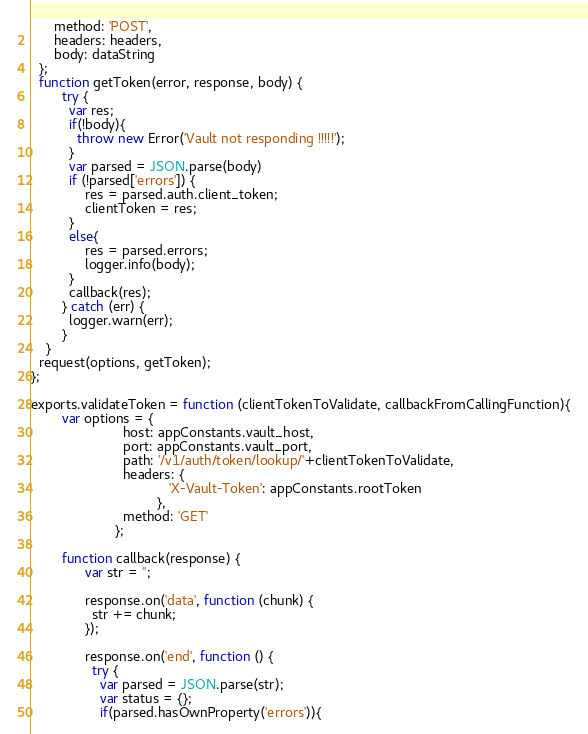<code> <loc_0><loc_0><loc_500><loc_500><_JavaScript_>      method: 'POST',
      headers: headers,
      body: dataString
  };
  function getToken(error, response, body) {
        try {
          var res;
          if(!body){
            throw new Error('Vault not responding !!!!!');
          }
          var parsed = JSON.parse(body)
          if (!parsed['errors']) {
              res = parsed.auth.client_token;
              clientToken = res;
          }
          else{
              res = parsed.errors;
              logger.info(body);
          }
          callback(res);
        } catch (err) {
          logger.warn(err);
        }
    }
  request(options, getToken);
};

exports.validateToken = function (clientTokenToValidate, callbackFromCallingFunction){
        var options = {
                        host: appConstants.vault_host,
                        port: appConstants.vault_port,
                        path: '/v1/auth/token/lookup/'+clientTokenToValidate,
                        headers: {
                                    'X-Vault-Token': appConstants.rootToken
                                 },
                        method: 'GET'
                      };

        function callback(response) {
              var str = '';

              response.on('data', function (chunk) {
                str += chunk;
              });

              response.on('end', function () {
                try {
                  var parsed = JSON.parse(str);
                  var status = {};
                  if(parsed.hasOwnProperty('errors')){</code> 